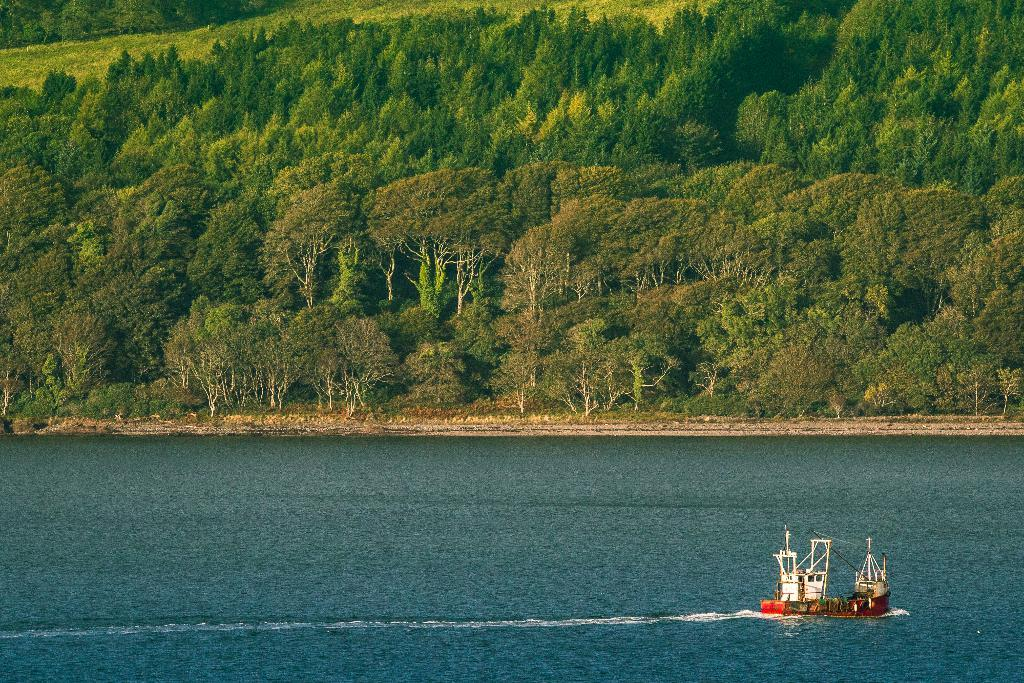What is the main subject of the image? The main subject of the image is a boat. Where is the boat located? The boat is on the water. What is the color of the water in the image? The water is blue in color. What can be seen in the background of the image? There are trees in the background of the image. What type of air is being used to power the boat in the image? The image does not provide information about the type of air or power source for the boat. How does the boat show care for the environment in the image? The image does not provide information about the boat's impact on the environment or any measures taken to show care for it. 